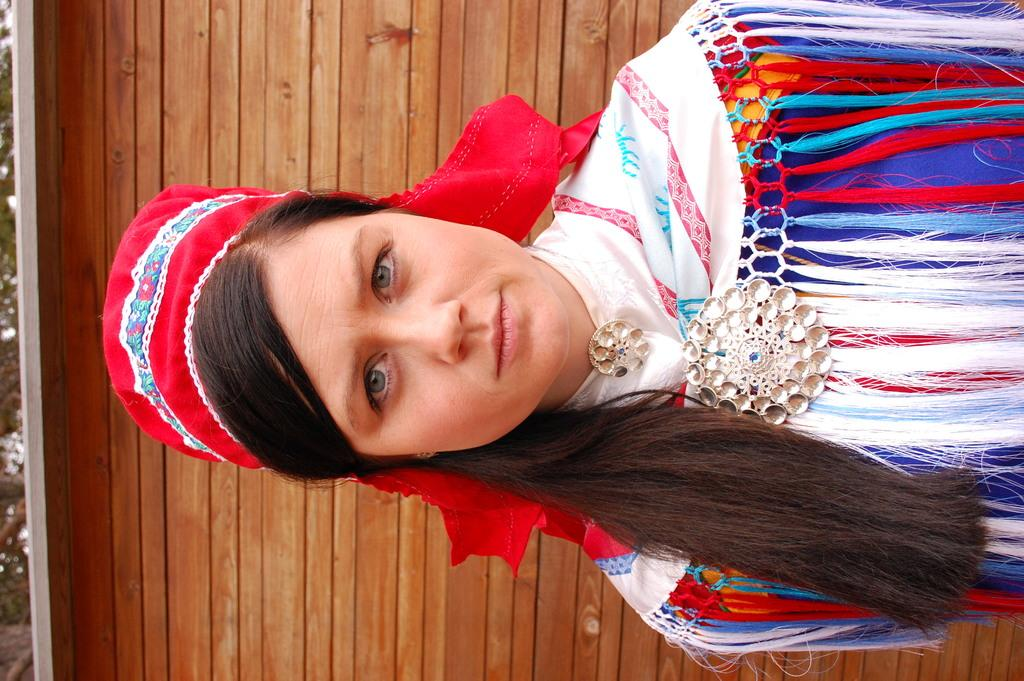Who is present in the image? There is a woman in the image. What is the woman wearing? The woman is wearing a blue and white color dress and a red color cap. What can be seen in the background of the image? There is a wooden wall in the background of the image. How many children are playing with a needle in the image? There are no children or needles present in the image. 